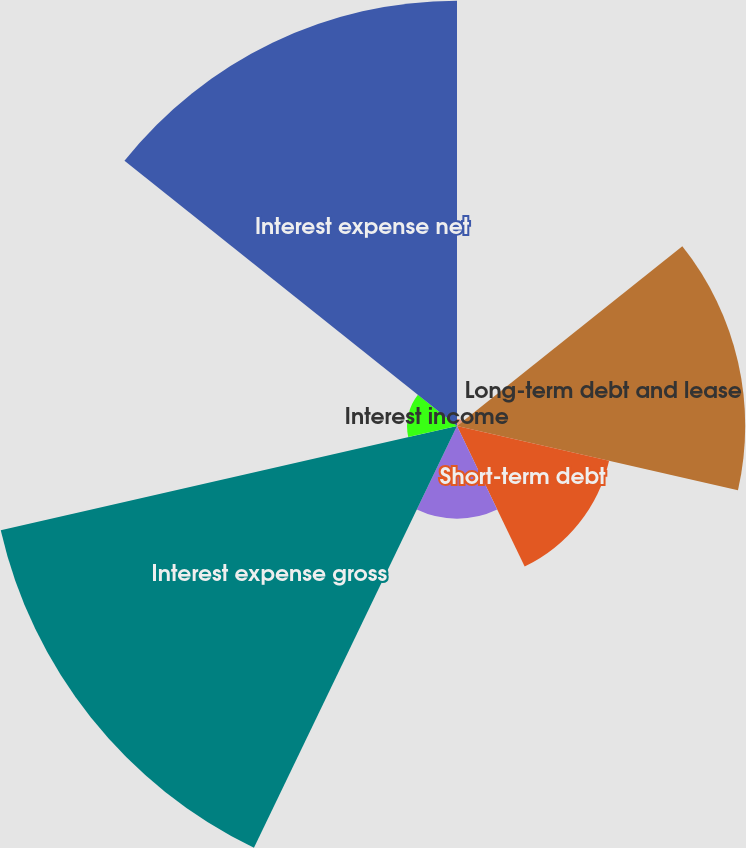Convert chart. <chart><loc_0><loc_0><loc_500><loc_500><pie_chart><fcel>For the years ended December<fcel>Long-term debt and lease<fcel>Short-term debt<fcel>Capitalized interest<fcel>Interest expense gross<fcel>Interest income<fcel>Interest expense net<nl><fcel>0.48%<fcel>19.38%<fcel>10.49%<fcel>6.23%<fcel>31.47%<fcel>3.36%<fcel>28.6%<nl></chart> 